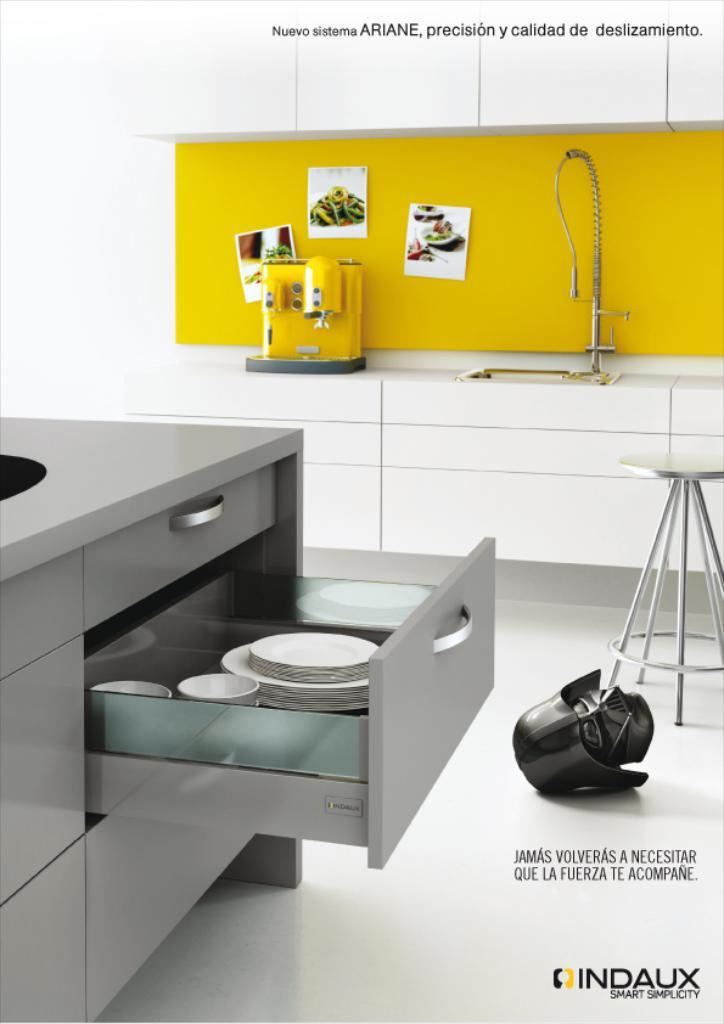What brand is advertised?
Give a very brief answer. Indaux. 